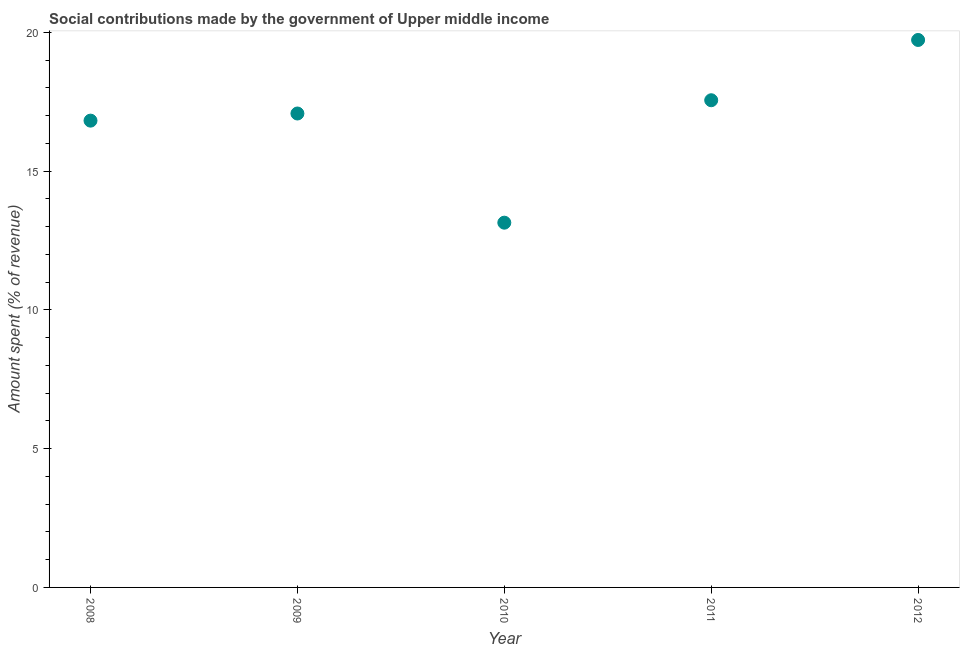What is the amount spent in making social contributions in 2008?
Offer a terse response. 16.82. Across all years, what is the maximum amount spent in making social contributions?
Your response must be concise. 19.73. Across all years, what is the minimum amount spent in making social contributions?
Your answer should be very brief. 13.14. In which year was the amount spent in making social contributions maximum?
Keep it short and to the point. 2012. In which year was the amount spent in making social contributions minimum?
Ensure brevity in your answer.  2010. What is the sum of the amount spent in making social contributions?
Give a very brief answer. 84.32. What is the difference between the amount spent in making social contributions in 2010 and 2011?
Your answer should be compact. -4.41. What is the average amount spent in making social contributions per year?
Give a very brief answer. 16.86. What is the median amount spent in making social contributions?
Make the answer very short. 17.08. In how many years, is the amount spent in making social contributions greater than 17 %?
Your response must be concise. 3. What is the ratio of the amount spent in making social contributions in 2010 to that in 2012?
Give a very brief answer. 0.67. Is the amount spent in making social contributions in 2010 less than that in 2012?
Offer a terse response. Yes. Is the difference between the amount spent in making social contributions in 2011 and 2012 greater than the difference between any two years?
Give a very brief answer. No. What is the difference between the highest and the second highest amount spent in making social contributions?
Provide a short and direct response. 2.17. What is the difference between the highest and the lowest amount spent in making social contributions?
Offer a terse response. 6.58. In how many years, is the amount spent in making social contributions greater than the average amount spent in making social contributions taken over all years?
Keep it short and to the point. 3. Does the graph contain any zero values?
Your answer should be very brief. No. Does the graph contain grids?
Provide a succinct answer. No. What is the title of the graph?
Offer a very short reply. Social contributions made by the government of Upper middle income. What is the label or title of the X-axis?
Provide a short and direct response. Year. What is the label or title of the Y-axis?
Keep it short and to the point. Amount spent (% of revenue). What is the Amount spent (% of revenue) in 2008?
Provide a succinct answer. 16.82. What is the Amount spent (% of revenue) in 2009?
Your answer should be very brief. 17.08. What is the Amount spent (% of revenue) in 2010?
Provide a succinct answer. 13.14. What is the Amount spent (% of revenue) in 2011?
Give a very brief answer. 17.55. What is the Amount spent (% of revenue) in 2012?
Provide a succinct answer. 19.73. What is the difference between the Amount spent (% of revenue) in 2008 and 2009?
Make the answer very short. -0.26. What is the difference between the Amount spent (% of revenue) in 2008 and 2010?
Provide a succinct answer. 3.68. What is the difference between the Amount spent (% of revenue) in 2008 and 2011?
Offer a very short reply. -0.73. What is the difference between the Amount spent (% of revenue) in 2008 and 2012?
Provide a short and direct response. -2.91. What is the difference between the Amount spent (% of revenue) in 2009 and 2010?
Keep it short and to the point. 3.93. What is the difference between the Amount spent (% of revenue) in 2009 and 2011?
Your answer should be compact. -0.48. What is the difference between the Amount spent (% of revenue) in 2009 and 2012?
Offer a very short reply. -2.65. What is the difference between the Amount spent (% of revenue) in 2010 and 2011?
Offer a terse response. -4.41. What is the difference between the Amount spent (% of revenue) in 2010 and 2012?
Offer a very short reply. -6.58. What is the difference between the Amount spent (% of revenue) in 2011 and 2012?
Give a very brief answer. -2.17. What is the ratio of the Amount spent (% of revenue) in 2008 to that in 2009?
Ensure brevity in your answer.  0.98. What is the ratio of the Amount spent (% of revenue) in 2008 to that in 2010?
Ensure brevity in your answer.  1.28. What is the ratio of the Amount spent (% of revenue) in 2008 to that in 2011?
Your answer should be compact. 0.96. What is the ratio of the Amount spent (% of revenue) in 2008 to that in 2012?
Your response must be concise. 0.85. What is the ratio of the Amount spent (% of revenue) in 2009 to that in 2010?
Your answer should be very brief. 1.3. What is the ratio of the Amount spent (% of revenue) in 2009 to that in 2011?
Keep it short and to the point. 0.97. What is the ratio of the Amount spent (% of revenue) in 2009 to that in 2012?
Offer a terse response. 0.87. What is the ratio of the Amount spent (% of revenue) in 2010 to that in 2011?
Keep it short and to the point. 0.75. What is the ratio of the Amount spent (% of revenue) in 2010 to that in 2012?
Keep it short and to the point. 0.67. What is the ratio of the Amount spent (% of revenue) in 2011 to that in 2012?
Your answer should be very brief. 0.89. 